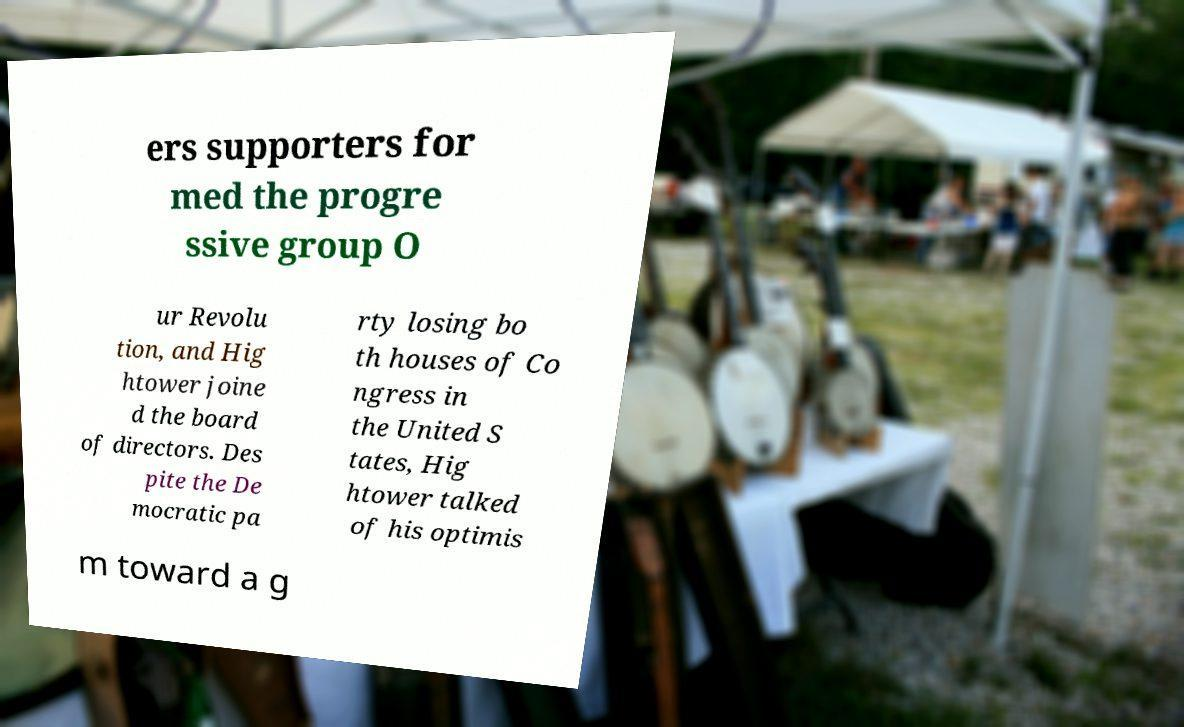Please read and relay the text visible in this image. What does it say? ers supporters for med the progre ssive group O ur Revolu tion, and Hig htower joine d the board of directors. Des pite the De mocratic pa rty losing bo th houses of Co ngress in the United S tates, Hig htower talked of his optimis m toward a g 